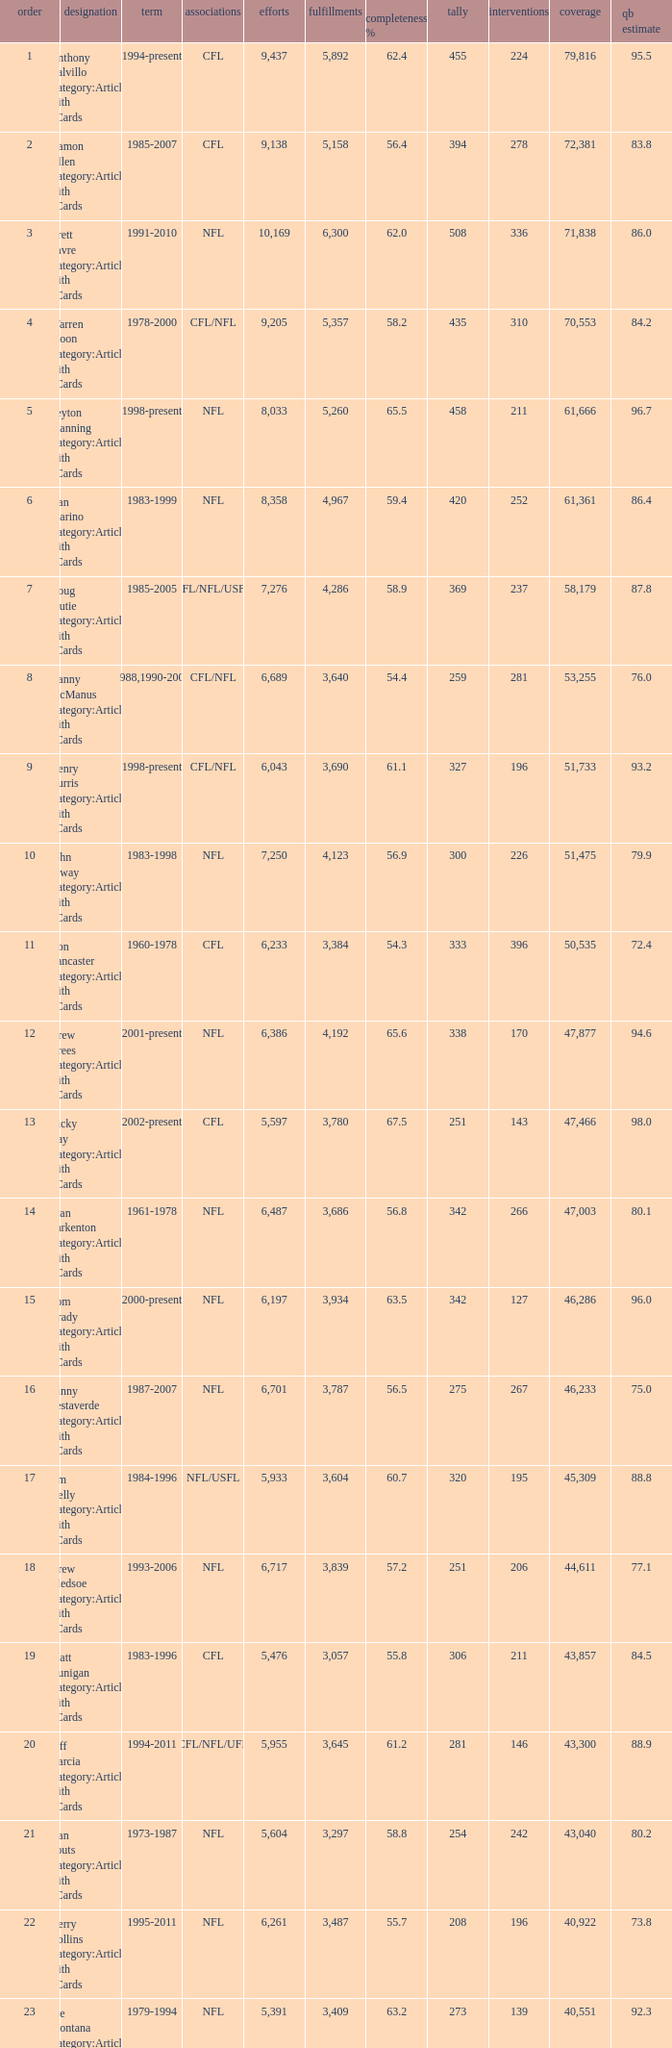Would you be able to parse every entry in this table? {'header': ['order', 'designation', 'term', 'associations', 'efforts', 'fulfillments', 'completeness %', 'tally', 'interventions', 'coverage', 'qb estimate'], 'rows': [['1', 'Anthony Calvillo Category:Articles with hCards', '1994-present', 'CFL', '9,437', '5,892', '62.4', '455', '224', '79,816', '95.5'], ['2', 'Damon Allen Category:Articles with hCards', '1985-2007', 'CFL', '9,138', '5,158', '56.4', '394', '278', '72,381', '83.8'], ['3', 'Brett Favre Category:Articles with hCards', '1991-2010', 'NFL', '10,169', '6,300', '62.0', '508', '336', '71,838', '86.0'], ['4', 'Warren Moon Category:Articles with hCards', '1978-2000', 'CFL/NFL', '9,205', '5,357', '58.2', '435', '310', '70,553', '84.2'], ['5', 'Peyton Manning Category:Articles with hCards', '1998-present', 'NFL', '8,033', '5,260', '65.5', '458', '211', '61,666', '96.7'], ['6', 'Dan Marino Category:Articles with hCards', '1983-1999', 'NFL', '8,358', '4,967', '59.4', '420', '252', '61,361', '86.4'], ['7', 'Doug Flutie Category:Articles with hCards', '1985-2005', 'CFL/NFL/USFL', '7,276', '4,286', '58.9', '369', '237', '58,179', '87.8'], ['8', 'Danny McManus Category:Articles with hCards', '1988,1990-2006', 'CFL/NFL', '6,689', '3,640', '54.4', '259', '281', '53,255', '76.0'], ['9', 'Henry Burris Category:Articles with hCards', '1998-present', 'CFL/NFL', '6,043', '3,690', '61.1', '327', '196', '51,733', '93.2'], ['10', 'John Elway Category:Articles with hCards', '1983-1998', 'NFL', '7,250', '4,123', '56.9', '300', '226', '51,475', '79.9'], ['11', 'Ron Lancaster Category:Articles with hCards', '1960-1978', 'CFL', '6,233', '3,384', '54.3', '333', '396', '50,535', '72.4'], ['12', 'Drew Brees Category:Articles with hCards', '2001-present', 'NFL', '6,386', '4,192', '65.6', '338', '170', '47,877', '94.6'], ['13', 'Ricky Ray Category:Articles with hCards', '2002-present', 'CFL', '5,597', '3,780', '67.5', '251', '143', '47,466', '98.0'], ['14', 'Fran Tarkenton Category:Articles with hCards', '1961-1978', 'NFL', '6,487', '3,686', '56.8', '342', '266', '47,003', '80.1'], ['15', 'Tom Brady Category:Articles with hCards', '2000-present', 'NFL', '6,197', '3,934', '63.5', '342', '127', '46,286', '96.0'], ['16', 'Vinny Testaverde Category:Articles with hCards', '1987-2007', 'NFL', '6,701', '3,787', '56.5', '275', '267', '46,233', '75.0'], ['17', 'Jim Kelly Category:Articles with hCards', '1984-1996', 'NFL/USFL', '5,933', '3,604', '60.7', '320', '195', '45,309', '88.8'], ['18', 'Drew Bledsoe Category:Articles with hCards', '1993-2006', 'NFL', '6,717', '3,839', '57.2', '251', '206', '44,611', '77.1'], ['19', 'Matt Dunigan Category:Articles with hCards', '1983-1996', 'CFL', '5,476', '3,057', '55.8', '306', '211', '43,857', '84.5'], ['20', 'Jeff Garcia Category:Articles with hCards', '1994-2011', 'CFL/NFL/UFL', '5,955', '3,645', '61.2', '281', '146', '43,300', '88.9'], ['21', 'Dan Fouts Category:Articles with hCards', '1973-1987', 'NFL', '5,604', '3,297', '58.8', '254', '242', '43,040', '80.2'], ['22', 'Kerry Collins Category:Articles with hCards', '1995-2011', 'NFL', '6,261', '3,487', '55.7', '208', '196', '40,922', '73.8'], ['23', 'Joe Montana Category:Articles with hCards', '1979-1994', 'NFL', '5,391', '3,409', '63.2', '273', '139', '40,551', '92.3'], ['24', 'Tracy Ham Category:Articles with hCards', '1987-1999', 'CFL', '4,945', '2,670', '54.0', '284', '164', '40,534', '86.6'], ['25', 'Johnny Unitas Category:Articles with hCards', '1956-1973', 'NFL', '5,186', '2,830', '54.6', '290', '253', '40,239', '78.2']]} What is the rank when there are more than 4,123 completion and the comp percentage is more than 65.6? None. 